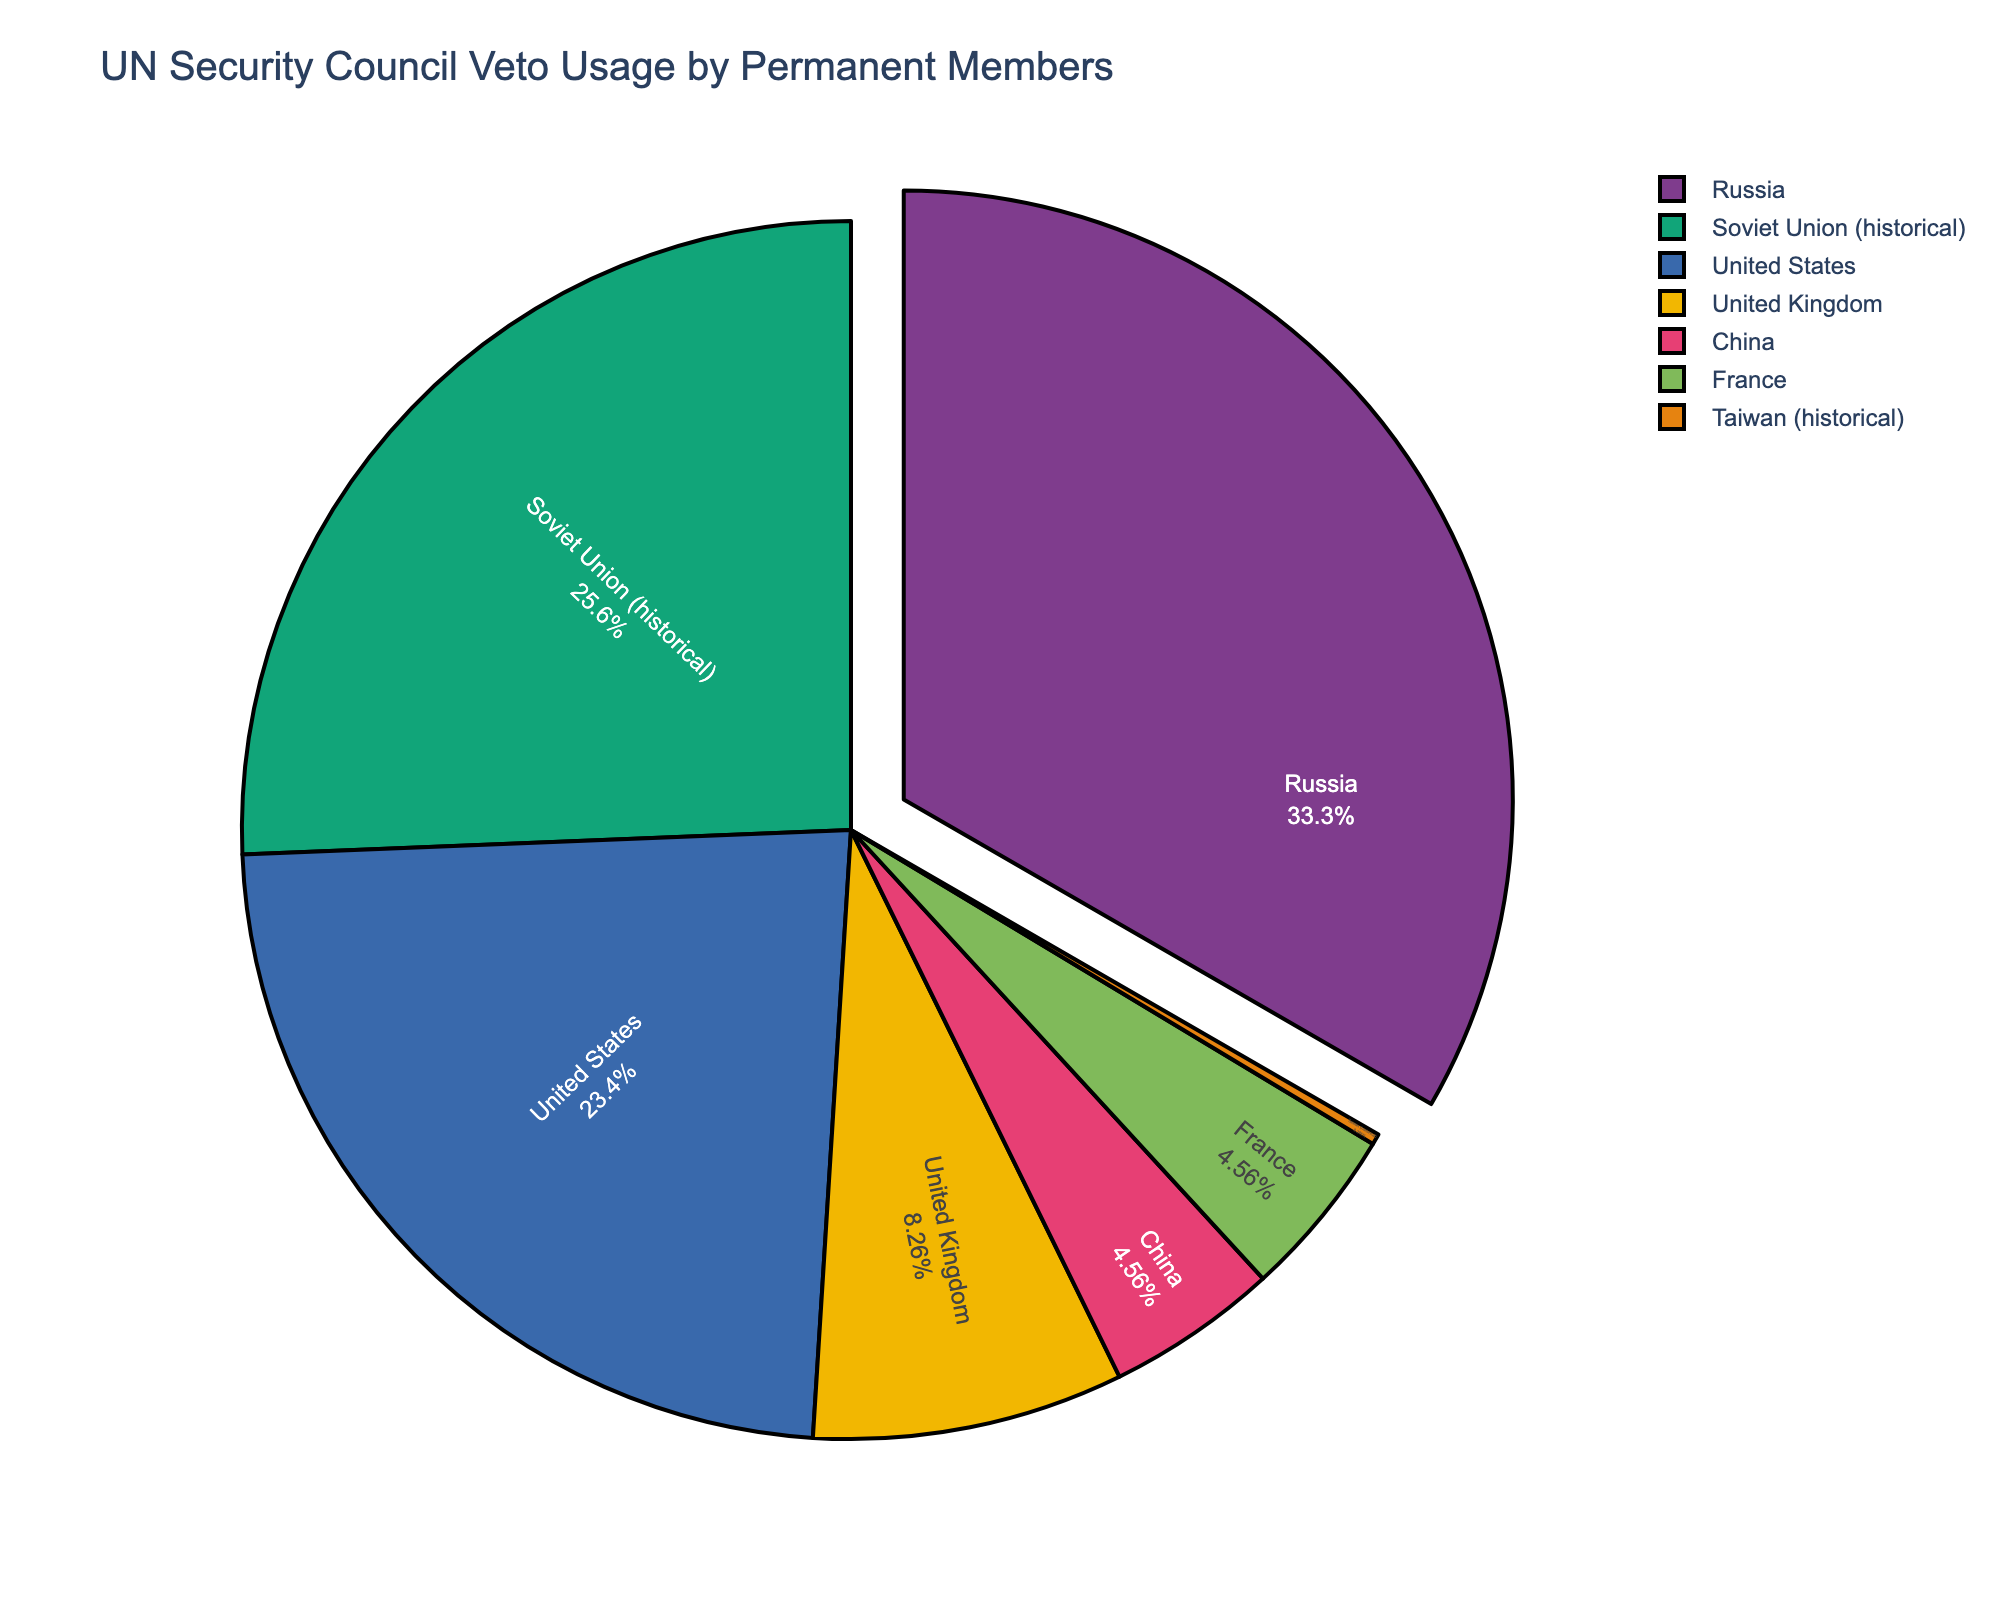Which country has used the veto power the most? By looking at the pie chart, the slice labeled "Russia" is the largest, indicating it has the highest count of veto usages.
Answer: Russia How many more vetoes have been used by Russia compared to the United States? Russia has 117 vetoes, and the United States has 82 vetoes. Subtracting 82 from 117 gives the difference.
Answer: 35 What proportion of vetoes has been used by permanent members other than Russia? Adding the veto counts of all countries other than Russia (82+16+29+16+90+1=234) and dividing by the total number of vetoes (117+234=351), then converting to percentage. 234/351 ≈ 0.667, or 66.7%.
Answer: 66.7% Which countries have used vetoes less frequently, China, France, or the United Kingdom? The pie chart segments show that China and France have the same count (16), and the United Kingdom has more vetoes (29).
Answer: China, France (both 16) What is the combined percentage of vetoes used by the Soviet Union and Russia? Adding the veto counts of Russia (117) and the Soviet Union (90) gives 207. Dividing by the total number of vetoes (351) and converting to percentage. 207/351 ≈ 0.59, or 59%.
Answer: 59% How does the usage of vetoes by the United States compare with that by the Soviet Union? The United States has used 82 vetoes, whereas the Soviet Union has used 90 vetoes. This means the Soviet Union has used 8 more vetoes than the United States.
Answer: The Soviet Union used 8 more Is the veto usage by Taiwan significantly different from the other permanent members? Taiwan's slice is extremely small, with only 1 veto, indicating it is significantly lower compared to the other countries' counts ranging from 16 to 117.
Answer: Yes, significantly lower What is the median count of vetoes among all the countries listed? Listing the counts: 1, 16, 16, 29, 82, 90, 117. The median is the middle value in an ordered list.
Answer: 29 Which country has used fewer vetoes: France or China, and by how many? Both France and China have used 16 vetoes each, so the difference is zero.
Answer: Same count, 0 difference What percentage of the total vetoes were used by historical members? Adding veto counts for the Soviet Union (90) and Taiwan (1) gives 91. Then dividing by the total vetoes of 351 and converting to percentage. 91/351 ≈ 0.259, or 25.9%.
Answer: 25.9% 